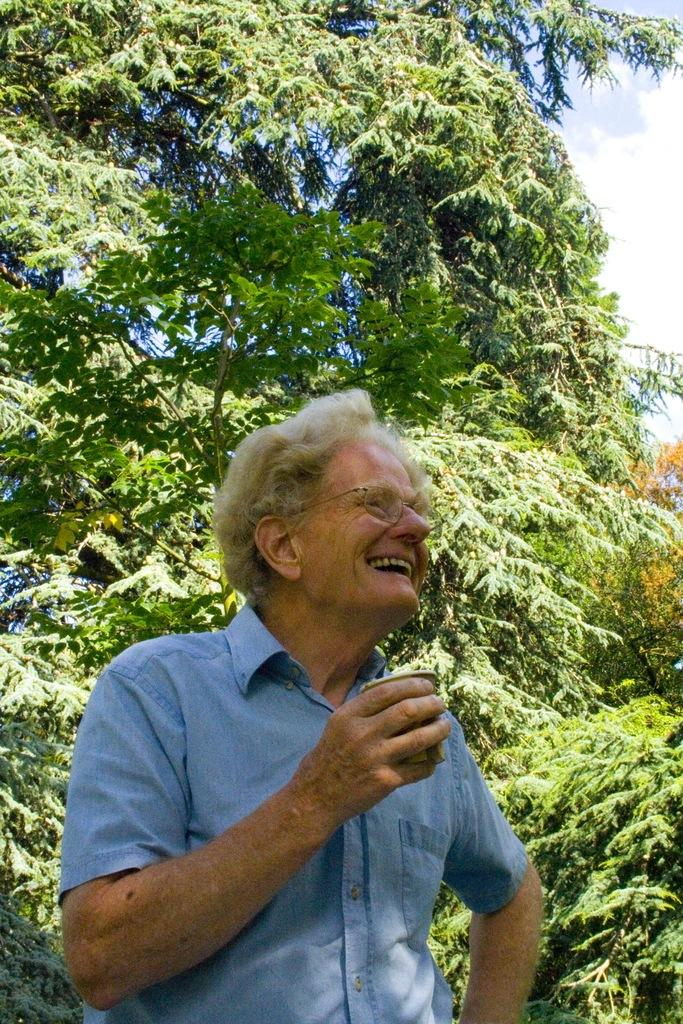Who is present in the image? There is a man in the picture. What is the man doing in the image? The man is smiling and holding a glass. What can be seen in the background of the image? There are trees visible in the picture. How would you describe the sky in the image? The sky is blue and cloudy. What type of watch is the man wearing in the image? There is no watch visible in the man in the image. 